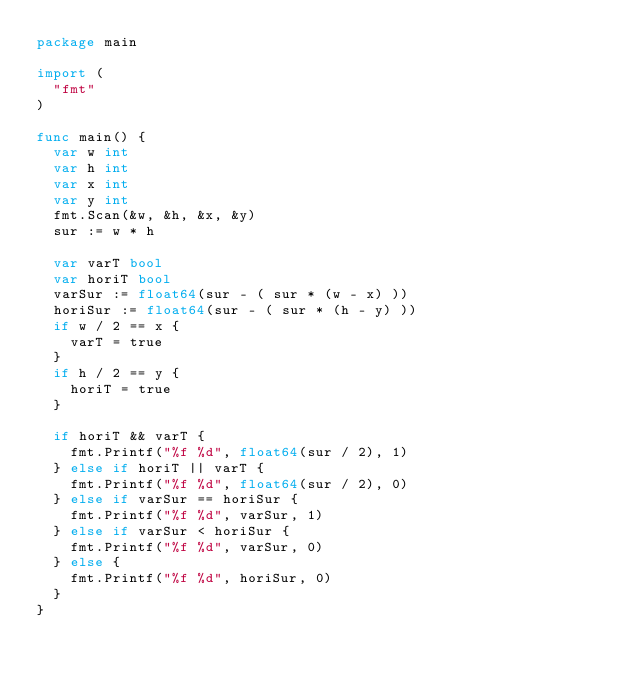Convert code to text. <code><loc_0><loc_0><loc_500><loc_500><_Go_>package main

import (
	"fmt"
)

func main() {
  var w int
  var h int
  var x int
  var y int
  fmt.Scan(&w, &h, &x, &y)
  sur := w * h
  
  var varT bool
  var horiT bool
  varSur := float64(sur - ( sur * (w - x) ))
  horiSur := float64(sur - ( sur * (h - y) ))
  if w / 2 == x {
    varT = true
  }
  if h / 2 == y {
    horiT = true
  }
  
  if horiT && varT {
    fmt.Printf("%f %d", float64(sur / 2), 1)
  } else if horiT || varT {
    fmt.Printf("%f %d", float64(sur / 2), 0)
  } else if varSur == horiSur {
    fmt.Printf("%f %d", varSur, 1)
  } else if varSur < horiSur {
    fmt.Printf("%f %d", varSur, 0)
  } else {
    fmt.Printf("%f %d", horiSur, 0)
  }
}</code> 